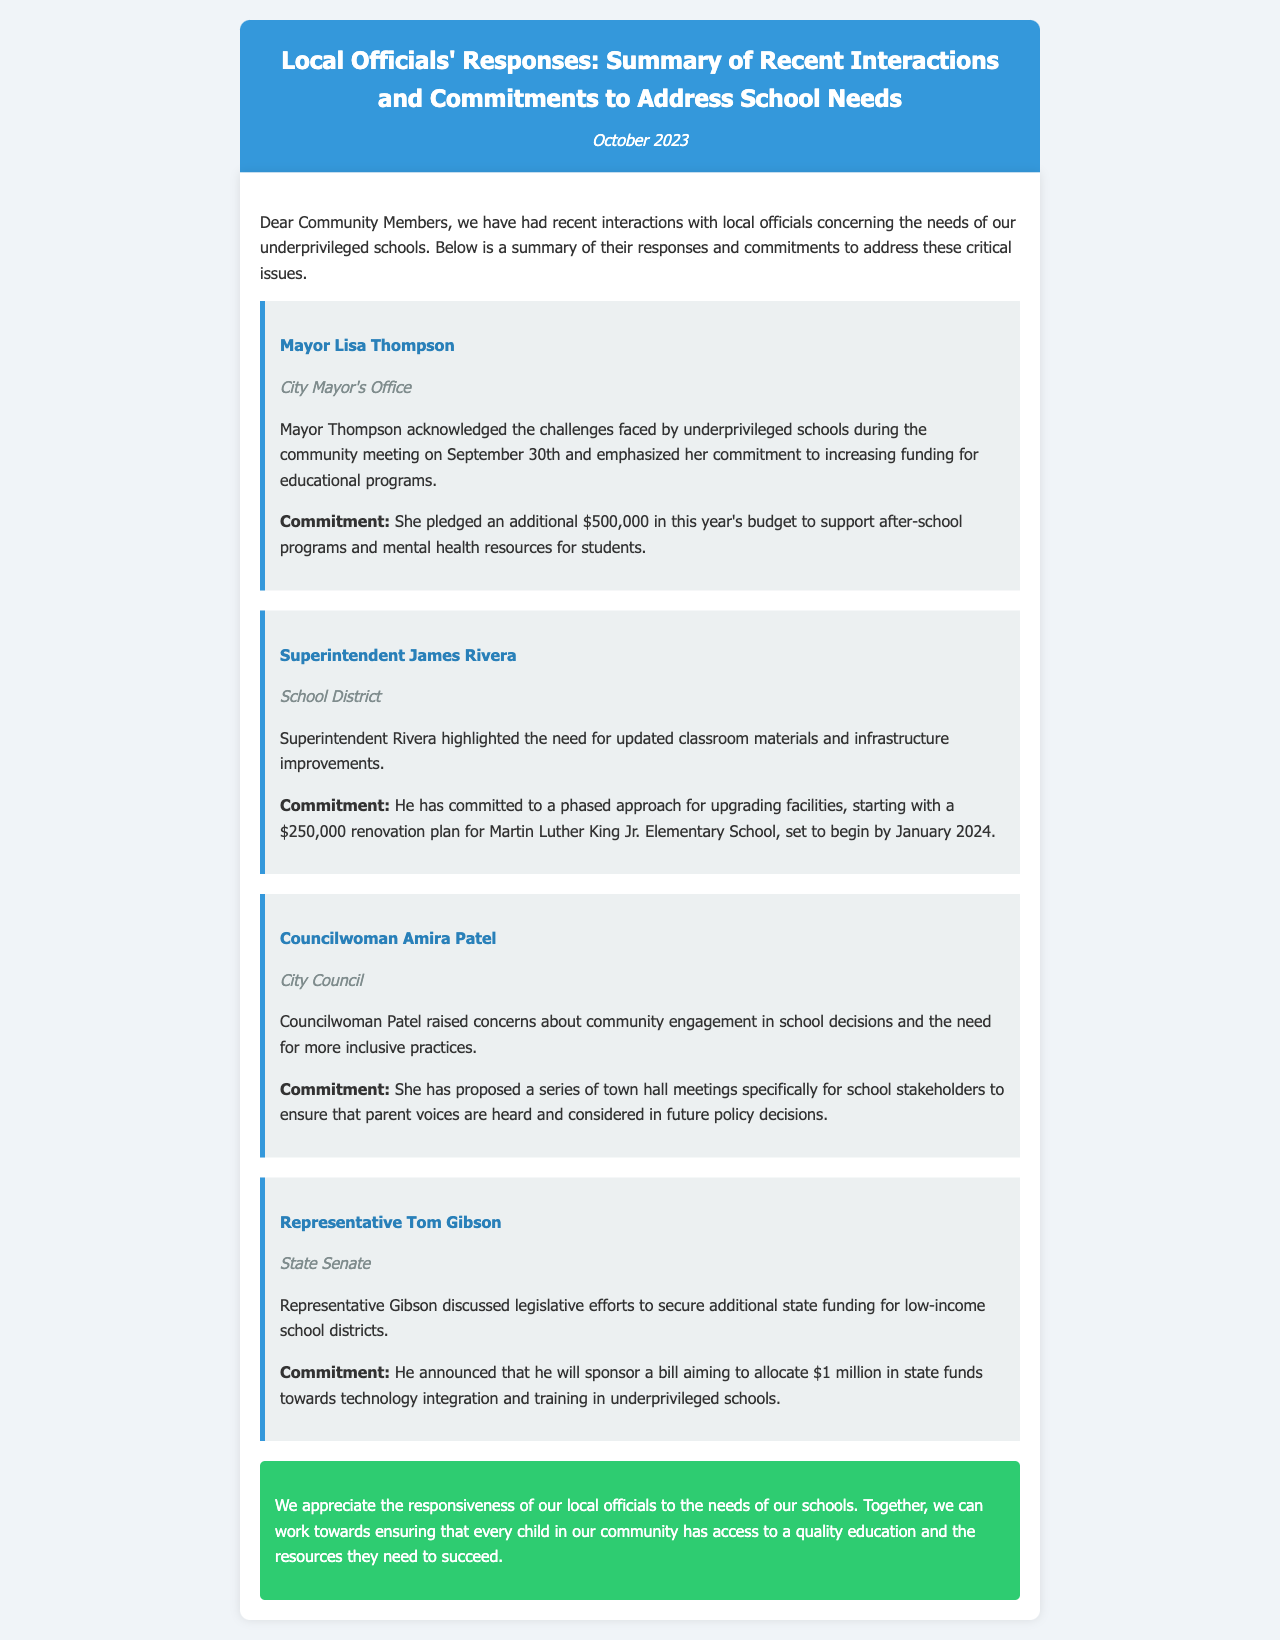what is the additional funding pledged by Mayor Thompson? Mayor Thompson pledged an additional $500,000 in this year's budget for educational programs.
Answer: $500,000 what is the start date for the renovation plan at Martin Luther King Jr. Elementary School? The renovation plan is set to begin by January 2024.
Answer: January 2024 who proposed town hall meetings for school stakeholders? Councilwoman Amira Patel proposed a series of town hall meetings for school stakeholders.
Answer: Councilwoman Amira Patel how much state funding will Representative Gibson sponsor for technology integration? Representative Gibson announced he will sponsor a bill to allocate $1 million in state funds for technology integration.
Answer: $1 million which official emphasized community engagement in school decisions? Councilwoman Amira Patel emphasized the need for community engagement in school decisions.
Answer: Councilwoman Amira Patel how much is the planned renovation budget for Martin Luther King Jr. Elementary School? The planned renovation budget for Martin Luther King Jr. Elementary School is $250,000.
Answer: $250,000 what was the date of the community meeting where Mayor Thompson spoke? The community meeting where Mayor Thompson spoke took place on September 30th.
Answer: September 30th what is the main focus of Mayor Thompson's commitment? Mayor Thompson's commitment focuses on increasing funding for after-school programs and mental health resources.
Answer: after-school programs and mental health resources what department does Superintendent James Rivera represent? Superintendent James Rivera represents the School District.
Answer: School District 